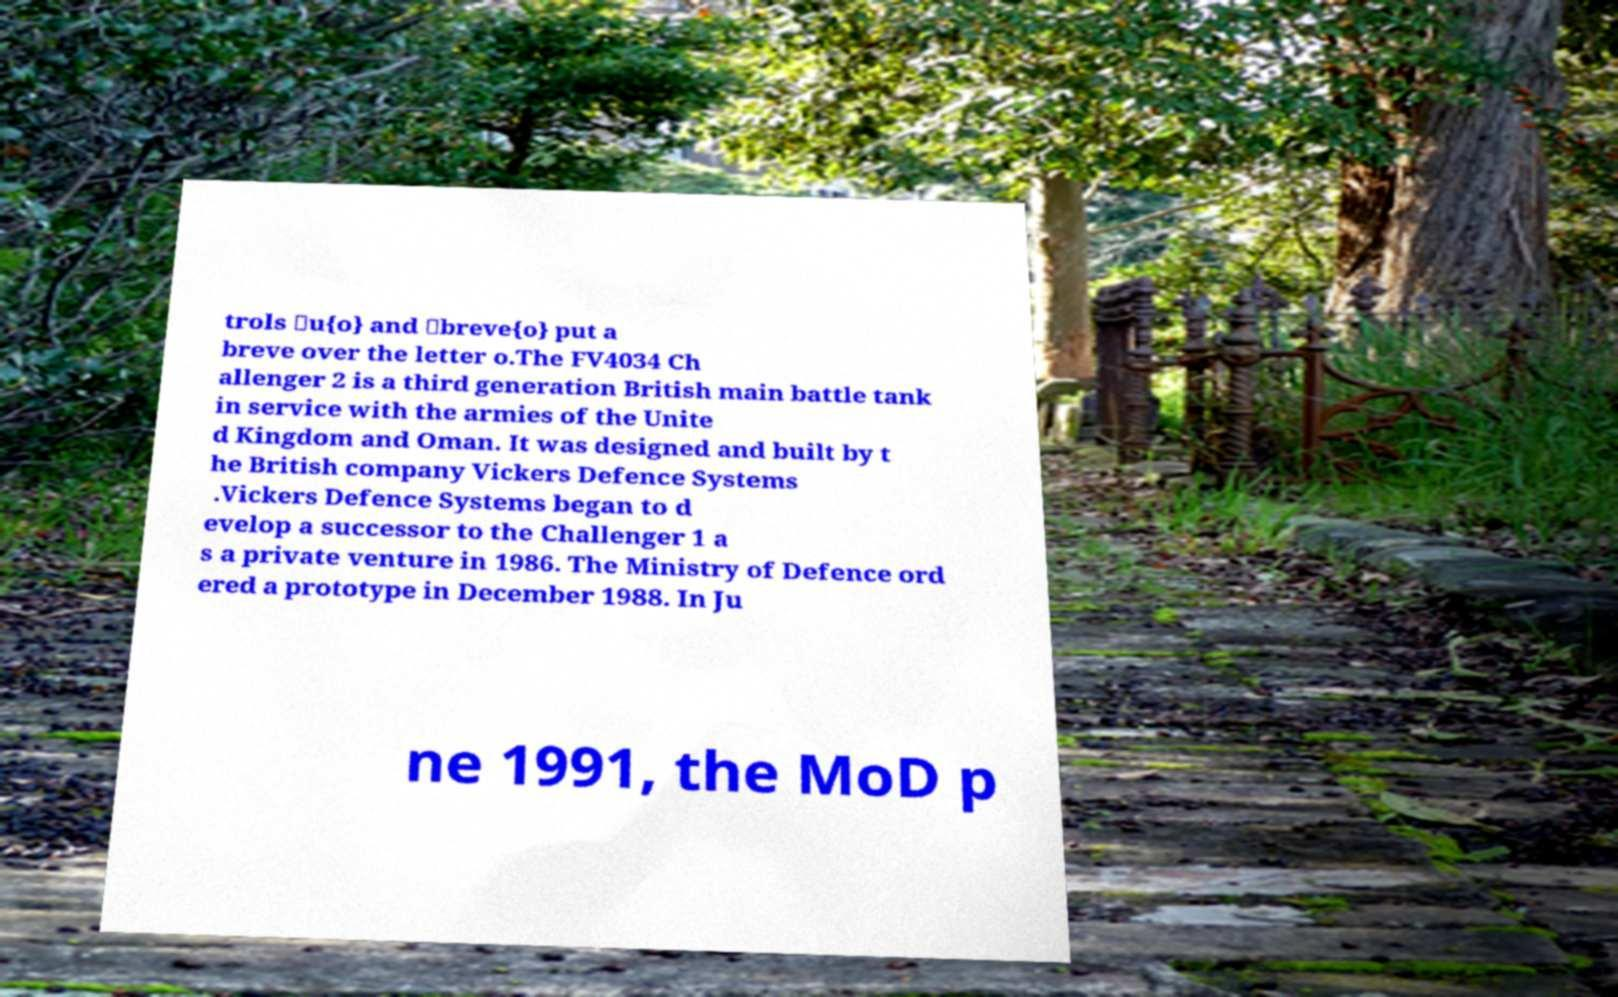For documentation purposes, I need the text within this image transcribed. Could you provide that? trols \u{o} and \breve{o} put a breve over the letter o.The FV4034 Ch allenger 2 is a third generation British main battle tank in service with the armies of the Unite d Kingdom and Oman. It was designed and built by t he British company Vickers Defence Systems .Vickers Defence Systems began to d evelop a successor to the Challenger 1 a s a private venture in 1986. The Ministry of Defence ord ered a prototype in December 1988. In Ju ne 1991, the MoD p 